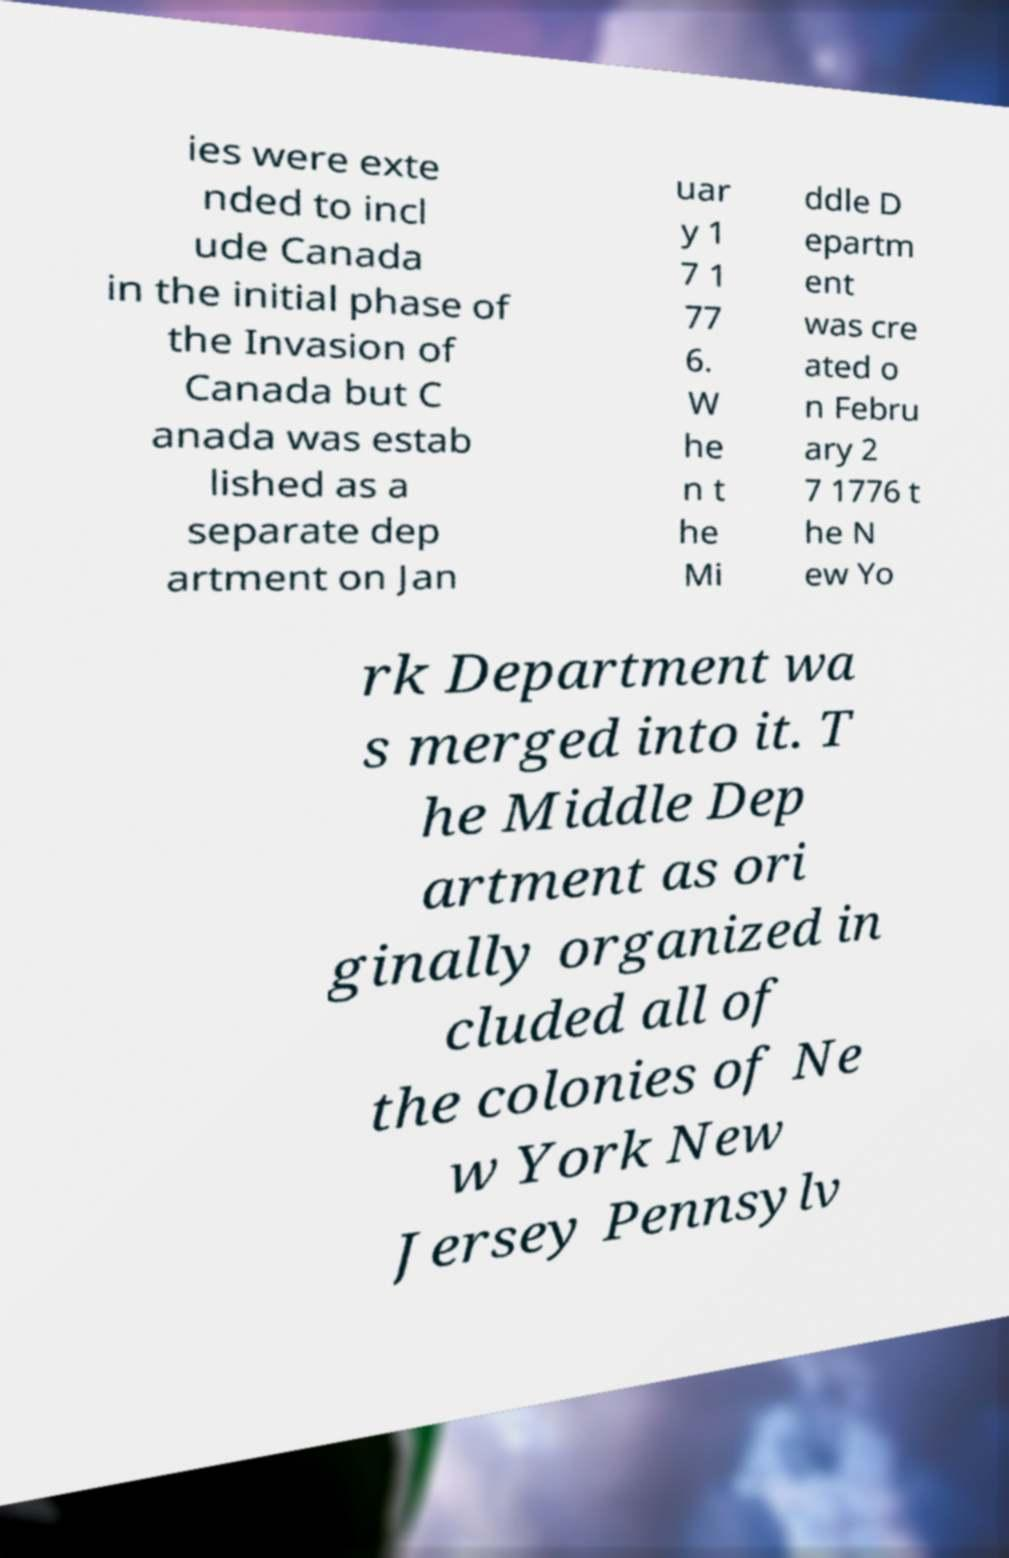For documentation purposes, I need the text within this image transcribed. Could you provide that? ies were exte nded to incl ude Canada in the initial phase of the Invasion of Canada but C anada was estab lished as a separate dep artment on Jan uar y 1 7 1 77 6. W he n t he Mi ddle D epartm ent was cre ated o n Febru ary 2 7 1776 t he N ew Yo rk Department wa s merged into it. T he Middle Dep artment as ori ginally organized in cluded all of the colonies of Ne w York New Jersey Pennsylv 